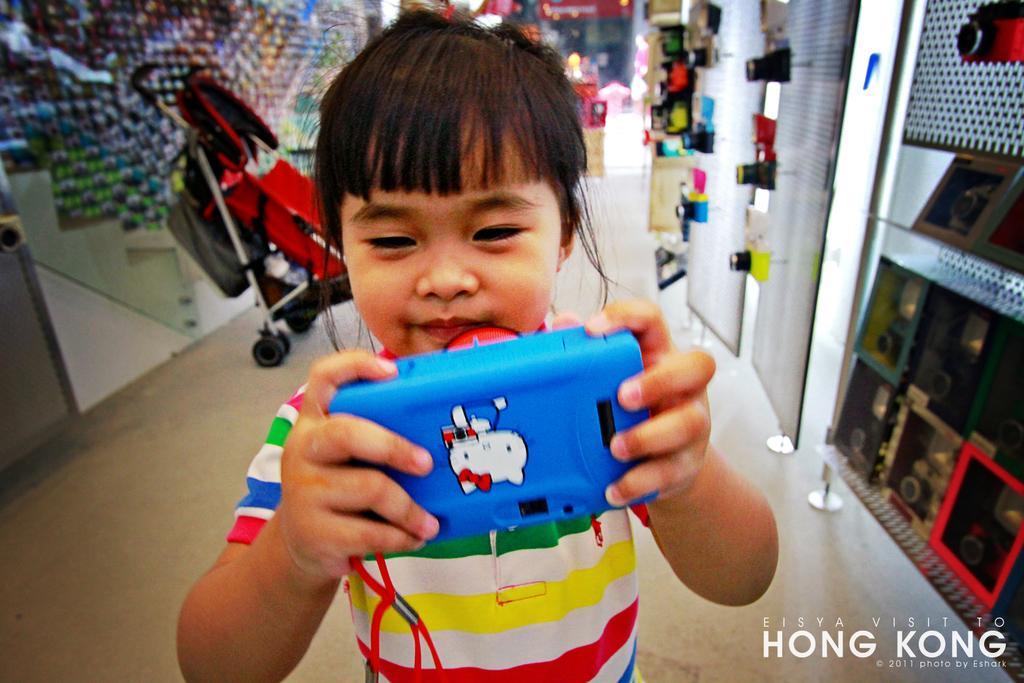In one or two sentences, can you explain what this image depicts? In this picture I can see a child who is holding a blue color thing and on it I see a sticker. In the background I see the walls and on the right side of this picture I see number of cameras and other things and on the bottom right of this image I see the watermark. 